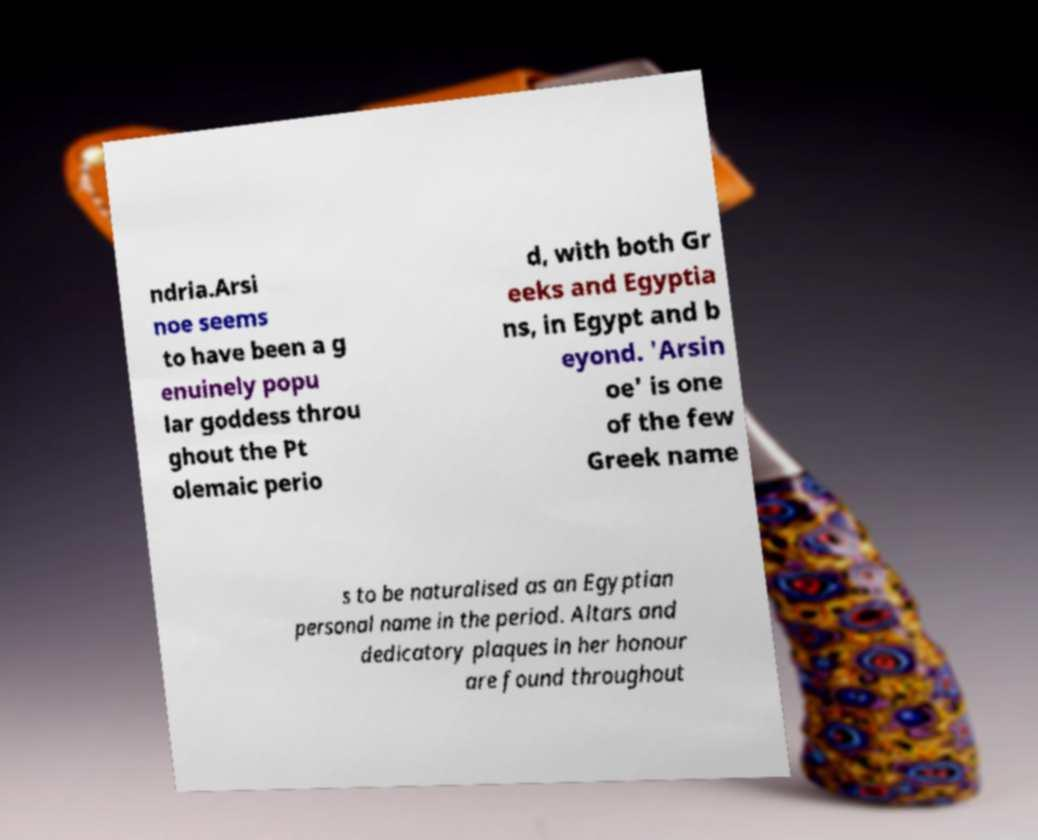For documentation purposes, I need the text within this image transcribed. Could you provide that? ndria.Arsi noe seems to have been a g enuinely popu lar goddess throu ghout the Pt olemaic perio d, with both Gr eeks and Egyptia ns, in Egypt and b eyond. 'Arsin oe' is one of the few Greek name s to be naturalised as an Egyptian personal name in the period. Altars and dedicatory plaques in her honour are found throughout 